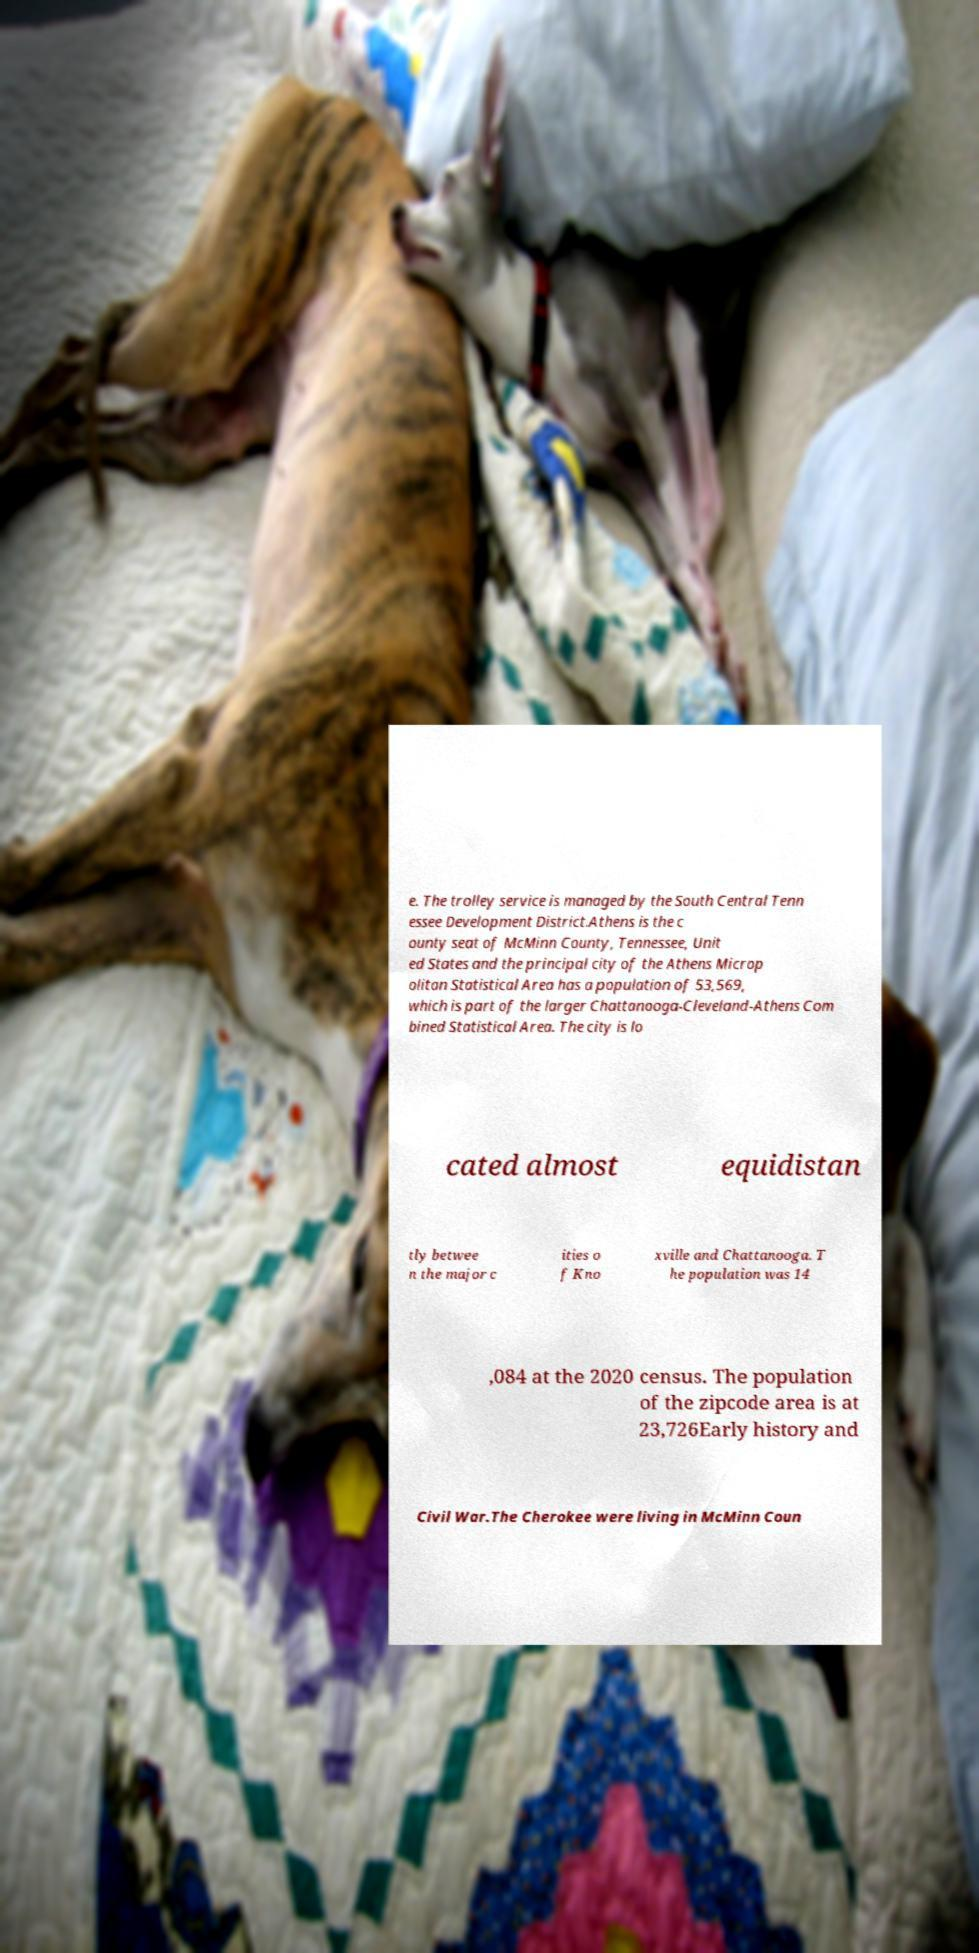There's text embedded in this image that I need extracted. Can you transcribe it verbatim? e. The trolley service is managed by the South Central Tenn essee Development District.Athens is the c ounty seat of McMinn County, Tennessee, Unit ed States and the principal city of the Athens Microp olitan Statistical Area has a population of 53,569, which is part of the larger Chattanooga-Cleveland-Athens Com bined Statistical Area. The city is lo cated almost equidistan tly betwee n the major c ities o f Kno xville and Chattanooga. T he population was 14 ,084 at the 2020 census. The population of the zipcode area is at 23,726Early history and Civil War.The Cherokee were living in McMinn Coun 